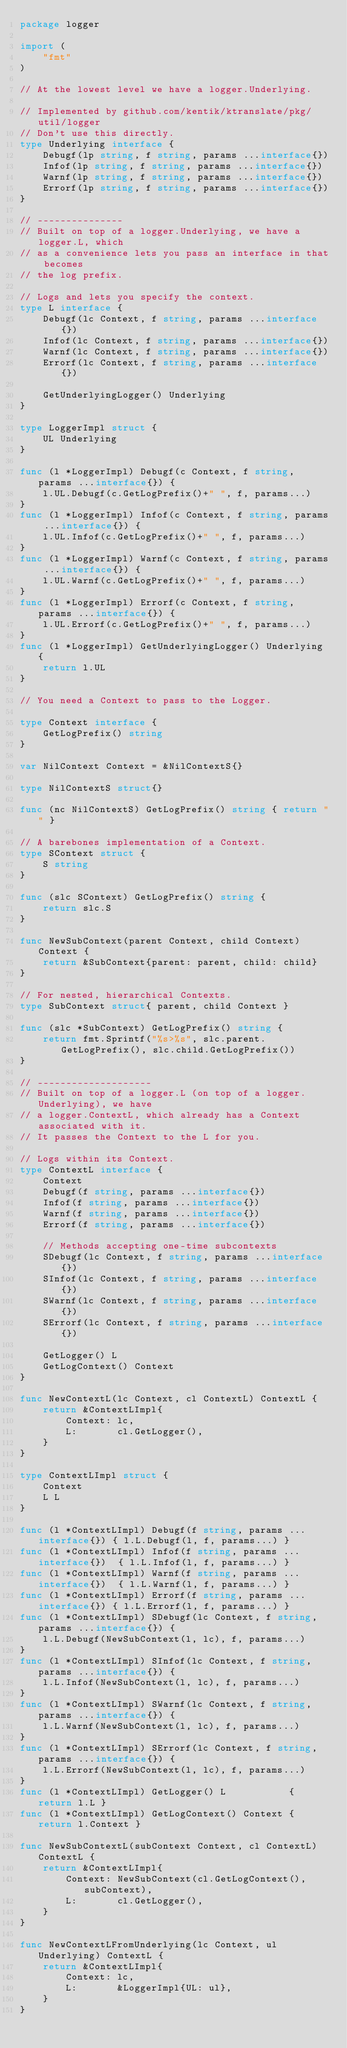<code> <loc_0><loc_0><loc_500><loc_500><_Go_>package logger

import (
	"fmt"
)

// At the lowest level we have a logger.Underlying.

// Implemented by github.com/kentik/ktranslate/pkg/util/logger
// Don't use this directly.
type Underlying interface {
	Debugf(lp string, f string, params ...interface{})
	Infof(lp string, f string, params ...interface{})
	Warnf(lp string, f string, params ...interface{})
	Errorf(lp string, f string, params ...interface{})
}

// ---------------
// Built on top of a logger.Underlying, we have a logger.L, which
// as a convenience lets you pass an interface in that becomes
// the log prefix.

// Logs and lets you specify the context.
type L interface {
	Debugf(lc Context, f string, params ...interface{})
	Infof(lc Context, f string, params ...interface{})
	Warnf(lc Context, f string, params ...interface{})
	Errorf(lc Context, f string, params ...interface{})

	GetUnderlyingLogger() Underlying
}

type LoggerImpl struct {
	UL Underlying
}

func (l *LoggerImpl) Debugf(c Context, f string, params ...interface{}) {
	l.UL.Debugf(c.GetLogPrefix()+" ", f, params...)
}
func (l *LoggerImpl) Infof(c Context, f string, params ...interface{}) {
	l.UL.Infof(c.GetLogPrefix()+" ", f, params...)
}
func (l *LoggerImpl) Warnf(c Context, f string, params ...interface{}) {
	l.UL.Warnf(c.GetLogPrefix()+" ", f, params...)
}
func (l *LoggerImpl) Errorf(c Context, f string, params ...interface{}) {
	l.UL.Errorf(c.GetLogPrefix()+" ", f, params...)
}
func (l *LoggerImpl) GetUnderlyingLogger() Underlying {
	return l.UL
}

// You need a Context to pass to the Logger.

type Context interface {
	GetLogPrefix() string
}

var NilContext Context = &NilContextS{}

type NilContextS struct{}

func (nc NilContextS) GetLogPrefix() string { return "" }

// A barebones implementation of a Context.
type SContext struct {
	S string
}

func (slc SContext) GetLogPrefix() string {
	return slc.S
}

func NewSubContext(parent Context, child Context) Context {
	return &SubContext{parent: parent, child: child}
}

// For nested, hierarchical Contexts.
type SubContext struct{ parent, child Context }

func (slc *SubContext) GetLogPrefix() string {
	return fmt.Sprintf("%s>%s", slc.parent.GetLogPrefix(), slc.child.GetLogPrefix())
}

// --------------------
// Built on top of a logger.L (on top of a logger.Underlying), we have
// a logger.ContextL, which already has a Context associated with it.
// It passes the Context to the L for you.

// Logs within its Context.
type ContextL interface {
	Context
	Debugf(f string, params ...interface{})
	Infof(f string, params ...interface{})
	Warnf(f string, params ...interface{})
	Errorf(f string, params ...interface{})

	// Methods accepting one-time subcontexts
	SDebugf(lc Context, f string, params ...interface{})
	SInfof(lc Context, f string, params ...interface{})
	SWarnf(lc Context, f string, params ...interface{})
	SErrorf(lc Context, f string, params ...interface{})

	GetLogger() L
	GetLogContext() Context
}

func NewContextL(lc Context, cl ContextL) ContextL {
	return &ContextLImpl{
		Context: lc,
		L:       cl.GetLogger(),
	}
}

type ContextLImpl struct {
	Context
	L L
}

func (l *ContextLImpl) Debugf(f string, params ...interface{}) { l.L.Debugf(l, f, params...) }
func (l *ContextLImpl) Infof(f string, params ...interface{})  { l.L.Infof(l, f, params...) }
func (l *ContextLImpl) Warnf(f string, params ...interface{})  { l.L.Warnf(l, f, params...) }
func (l *ContextLImpl) Errorf(f string, params ...interface{}) { l.L.Errorf(l, f, params...) }
func (l *ContextLImpl) SDebugf(lc Context, f string, params ...interface{}) {
	l.L.Debugf(NewSubContext(l, lc), f, params...)
}
func (l *ContextLImpl) SInfof(lc Context, f string, params ...interface{}) {
	l.L.Infof(NewSubContext(l, lc), f, params...)
}
func (l *ContextLImpl) SWarnf(lc Context, f string, params ...interface{}) {
	l.L.Warnf(NewSubContext(l, lc), f, params...)
}
func (l *ContextLImpl) SErrorf(lc Context, f string, params ...interface{}) {
	l.L.Errorf(NewSubContext(l, lc), f, params...)
}
func (l *ContextLImpl) GetLogger() L           { return l.L }
func (l *ContextLImpl) GetLogContext() Context { return l.Context }

func NewSubContextL(subContext Context, cl ContextL) ContextL {
	return &ContextLImpl{
		Context: NewSubContext(cl.GetLogContext(), subContext),
		L:       cl.GetLogger(),
	}
}

func NewContextLFromUnderlying(lc Context, ul Underlying) ContextL {
	return &ContextLImpl{
		Context: lc,
		L:       &LoggerImpl{UL: ul},
	}
}
</code> 